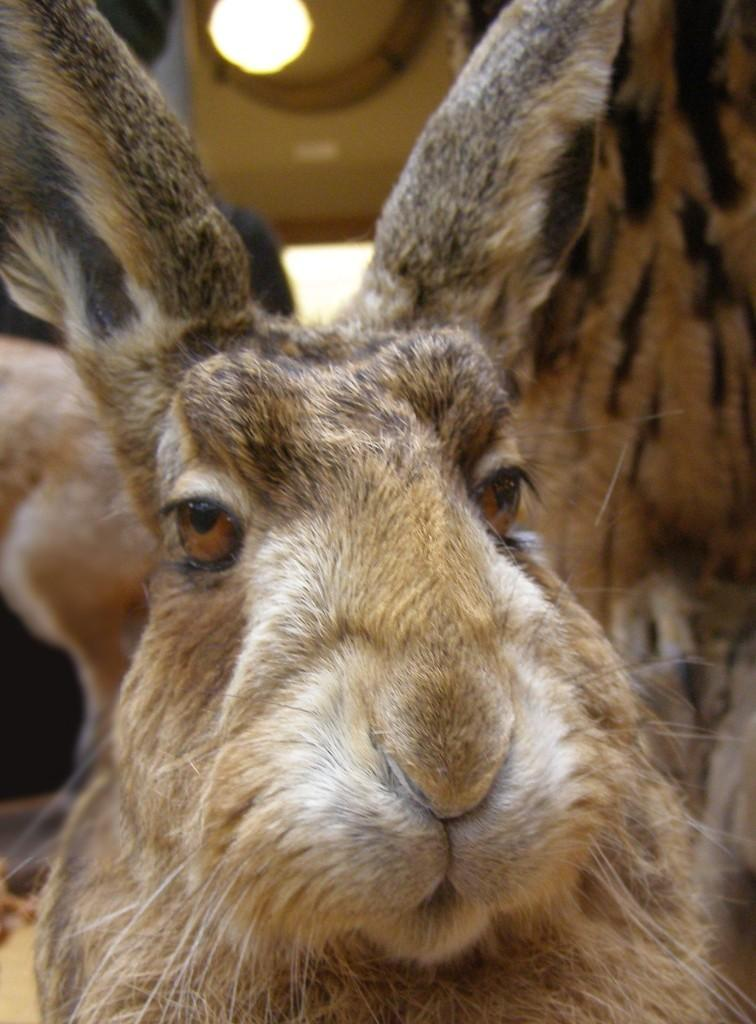What animal is in the picture? There is a rabbit in the picture. How many ears does the rabbit have? The rabbit has two ears. What facial features does the rabbit have? The rabbit has eyes, a nose, and a mouth. What is a distinctive feature of the rabbit? The rabbit has whiskers. What object is visible in the picture besides the rabbit? There is a bulb visible in the picture. What type of government is depicted in the image? There is no depiction of a government in the image; it features a rabbit and a bulb. Can you tell me how many grapes are in the rabbit's mouth? There are no grapes present in the image; the rabbit has a mouth but no grapes are visible. 